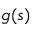<formula> <loc_0><loc_0><loc_500><loc_500>g ( s )</formula> 